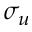<formula> <loc_0><loc_0><loc_500><loc_500>\sigma _ { u }</formula> 